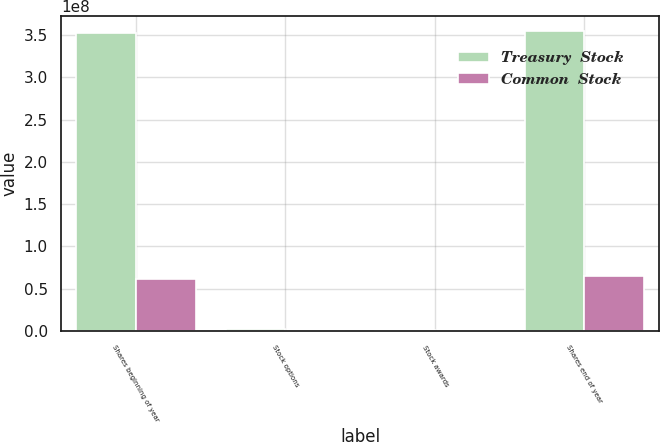Convert chart. <chart><loc_0><loc_0><loc_500><loc_500><stacked_bar_chart><ecel><fcel>Shares beginning of year<fcel>Stock options<fcel>Stock awards<fcel>Shares end of year<nl><fcel>Treasury  Stock<fcel>3.52608e+08<fcel>1.71421e+06<fcel>393941<fcel>3.54716e+08<nl><fcel>Common  Stock<fcel>6.07827e+07<fcel>41767<fcel>55431<fcel>6.53931e+07<nl></chart> 